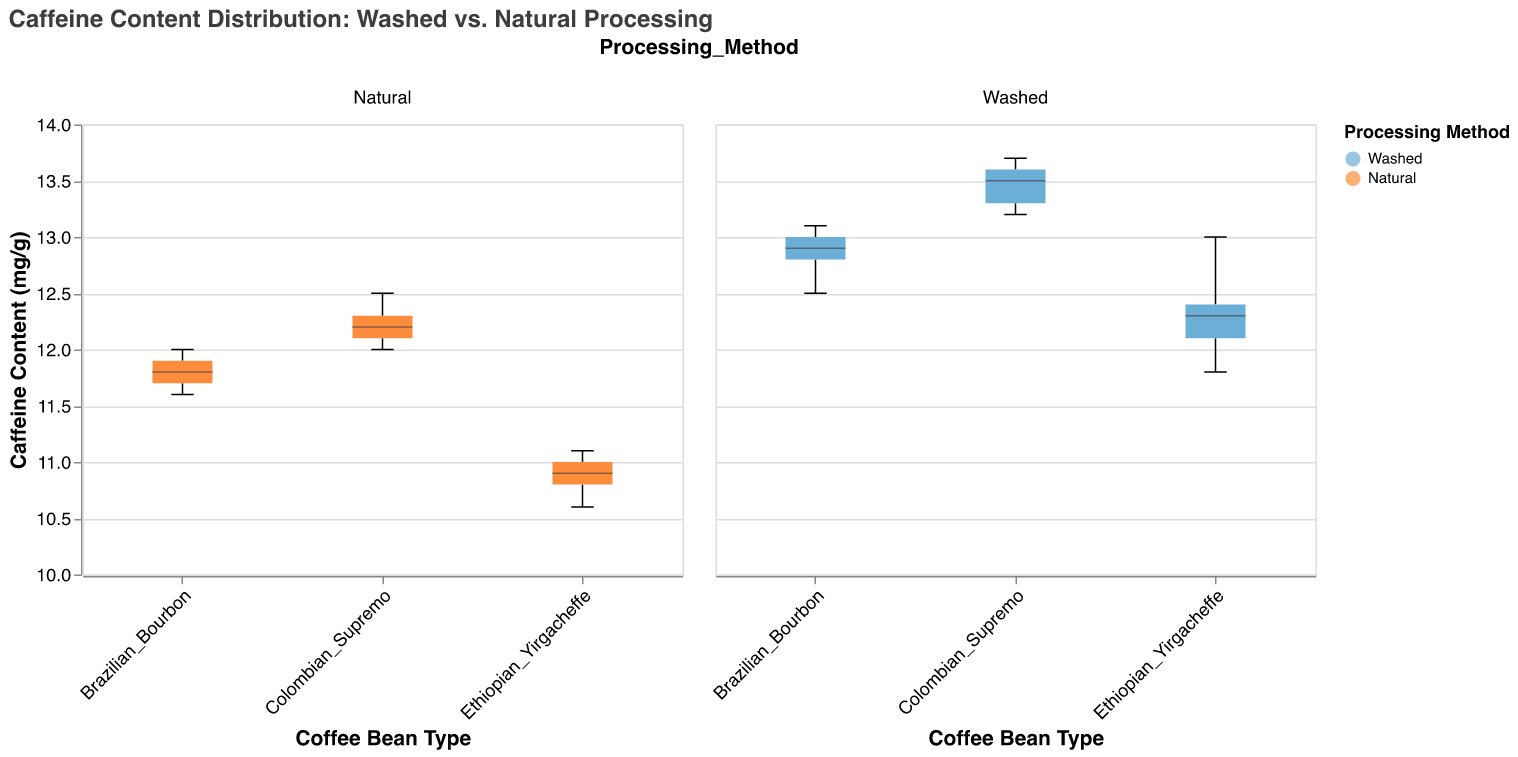What is the title of the figure? The title can be found at the top of the figure and states what the overall plot is about.
Answer: Caffeine Content Distribution: Washed vs. Natural Processing What is the color used for the washed processing method in the plot? By observing the legend associated with the plot, we can see the color used for each processing method.
Answer: Light blue Which coffee bean type has the highest median caffeine content? To find the highest median caffeine content, compare the median lines (usually bold lines in the center) in the box plots for each coffee bean type.
Answer: Colombian Supremo (Washed) What is the range of caffeine content for Ethiopian Yirgacheffe (Washed)? The range is determined by the lowest and highest lines of the box plot corresponding to Ethiopian Yirgacheffe (Washed).
Answer: 11.8 to 13.0 mg/g Compare the median caffeine content of Brazilian Bourbon between washed and natural processing methods. Look at the median lines for both washed and natural methods for Brazilian Bourbon and compare their values.
Answer: Washed = 12.8 mg/g, Natural = 11.8 mg/g What is the difference in the upper quartile caffeine content between washed and natural processed Ethiopian Yirgacheffe? Identify the point corresponding to the upper quartile (usually the top of the box) for both washed and natural processed Ethiopian Yirgacheffe, then subtract the natural value from the washed value.
Answer: 13.0 mg/g - 11.0 mg/g = 2 mg/g Which processing method has a broader interquartile range (IQR) for Brazilian Bourbon? The IQR is the range between the bottom and top of the box in the box plot. Compare the lengths of the boxes for both processing methods for Brazilian Bourbon.
Answer: Washed In general, does washed or natural processing result in a higher median caffeine content? Compare the median lines of each bean type under both processing methods. Sum up the observations for a more general understanding.
Answer: Washed How many different coffee bean types are shown in the figure? Count the distinct categories fixed on the x-axis in terms of coffee bean types.
Answer: Three Is there any overlap between the ranges of caffeine content for washed and natural processing for Colombian Supremo? Examine the whiskers (lines extending from the boxes) and check whether they overlap for Colombian Supremo.
Answer: Yes 